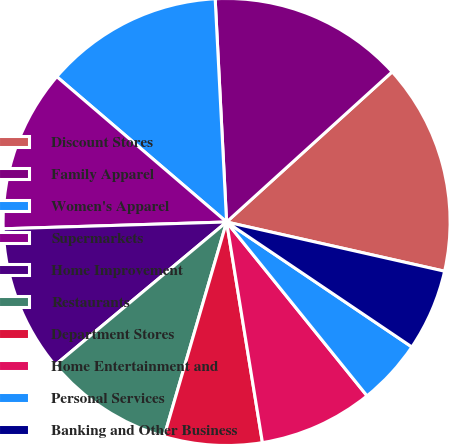Convert chart to OTSL. <chart><loc_0><loc_0><loc_500><loc_500><pie_chart><fcel>Discount Stores<fcel>Family Apparel<fcel>Women's Apparel<fcel>Supermarkets<fcel>Home Improvement<fcel>Restaurants<fcel>Department Stores<fcel>Home Entertainment and<fcel>Personal Services<fcel>Banking and Other Business<nl><fcel>15.26%<fcel>14.09%<fcel>12.92%<fcel>11.75%<fcel>10.58%<fcel>9.42%<fcel>7.08%<fcel>8.25%<fcel>4.74%<fcel>5.91%<nl></chart> 